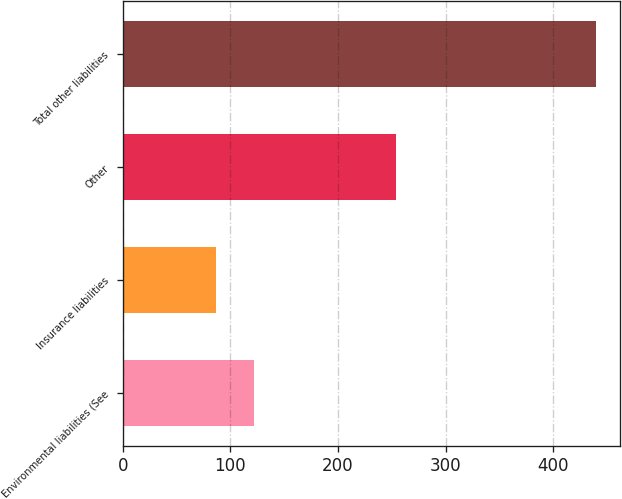Convert chart. <chart><loc_0><loc_0><loc_500><loc_500><bar_chart><fcel>Environmental liabilities (See<fcel>Insurance liabilities<fcel>Other<fcel>Total other liabilities<nl><fcel>122.3<fcel>87<fcel>254<fcel>440<nl></chart> 